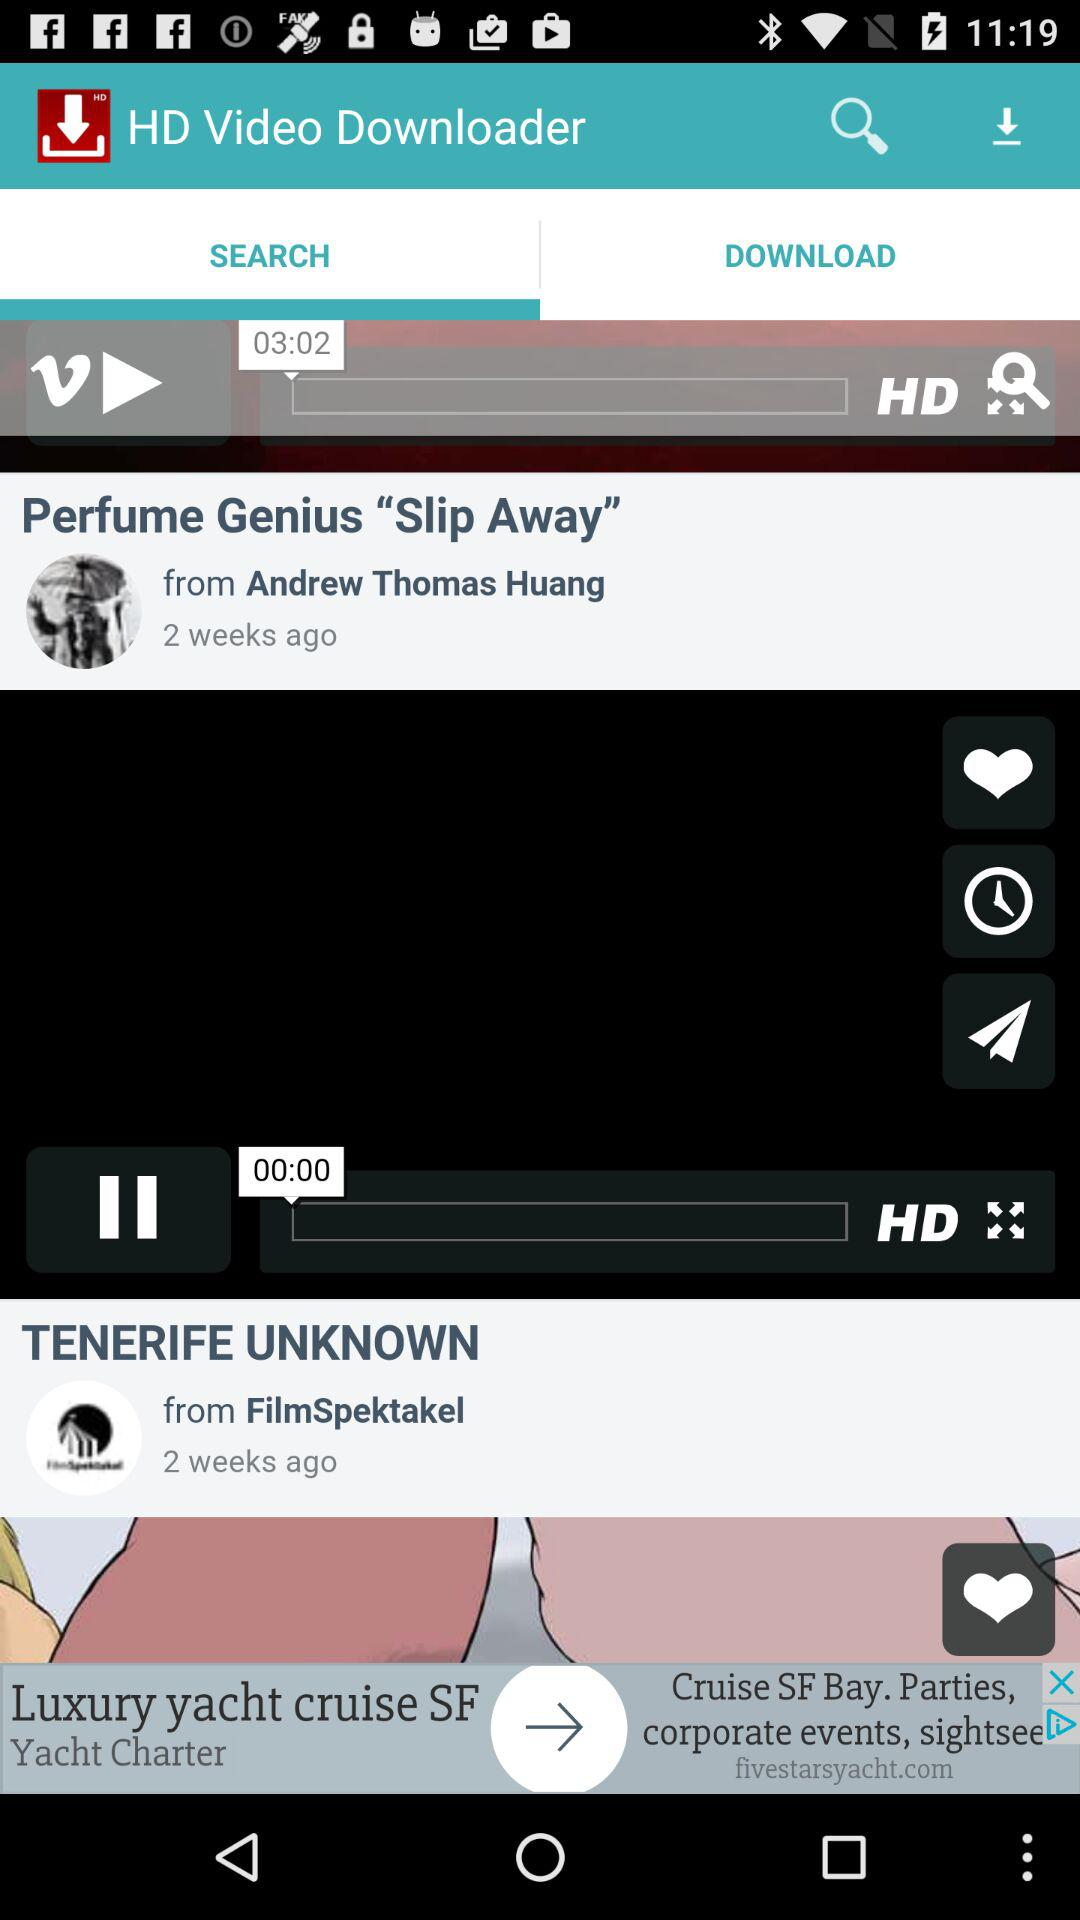Which tab is currently selected? The currently selected tab is "SEARCH". 